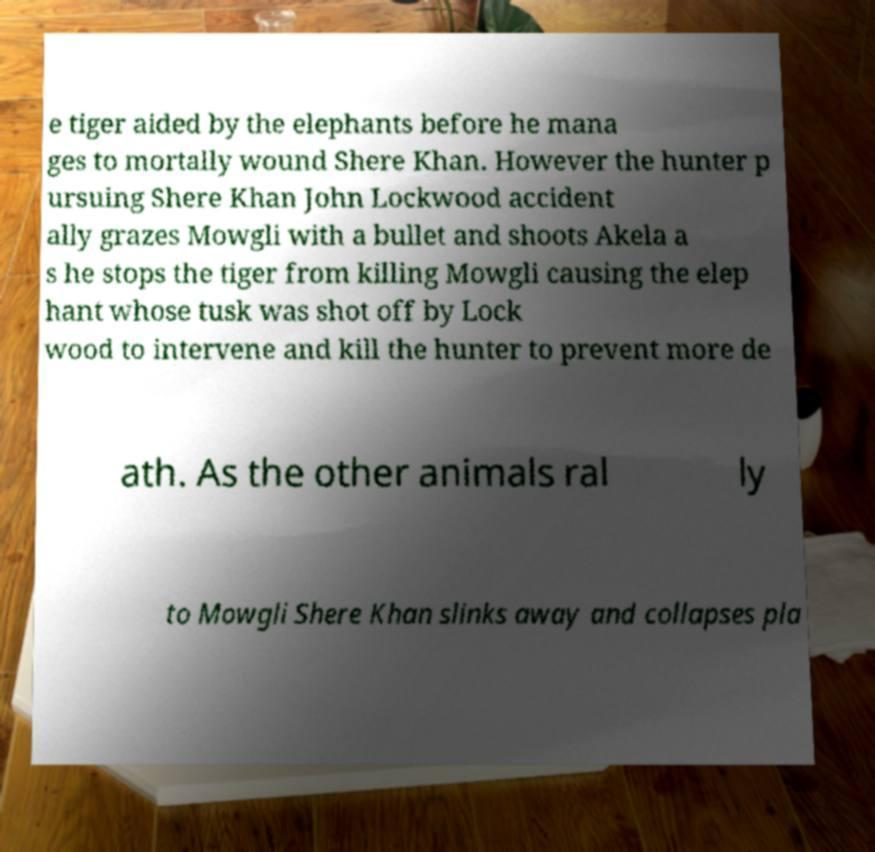There's text embedded in this image that I need extracted. Can you transcribe it verbatim? e tiger aided by the elephants before he mana ges to mortally wound Shere Khan. However the hunter p ursuing Shere Khan John Lockwood accident ally grazes Mowgli with a bullet and shoots Akela a s he stops the tiger from killing Mowgli causing the elep hant whose tusk was shot off by Lock wood to intervene and kill the hunter to prevent more de ath. As the other animals ral ly to Mowgli Shere Khan slinks away and collapses pla 